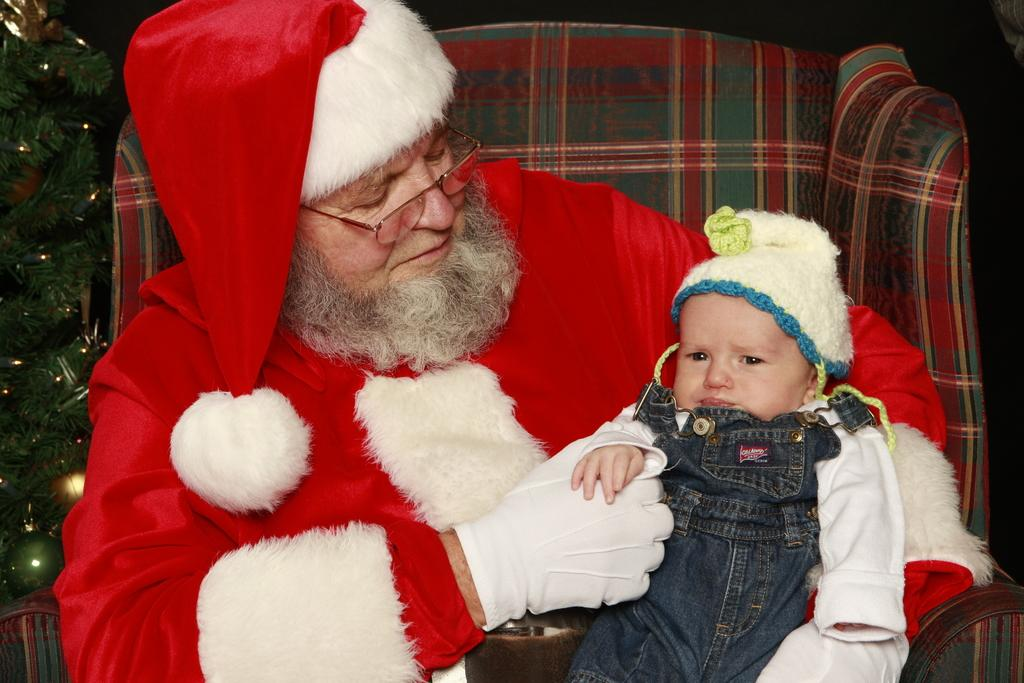What is the person in the image wearing? The person is wearing a Santa's costume in the image. Where is the person sitting? The person is sitting on a couch. Who is with the person in the image? There is a child on the person's lap. What can be seen beside the person? There is a Christmas tree beside the person. How would you describe the lighting in the image? The background of the image is dark. What type of school is visible in the image? There is no school present in the image. Can you see a flock of birds in the image? There is no flock of birds visible in the image. 